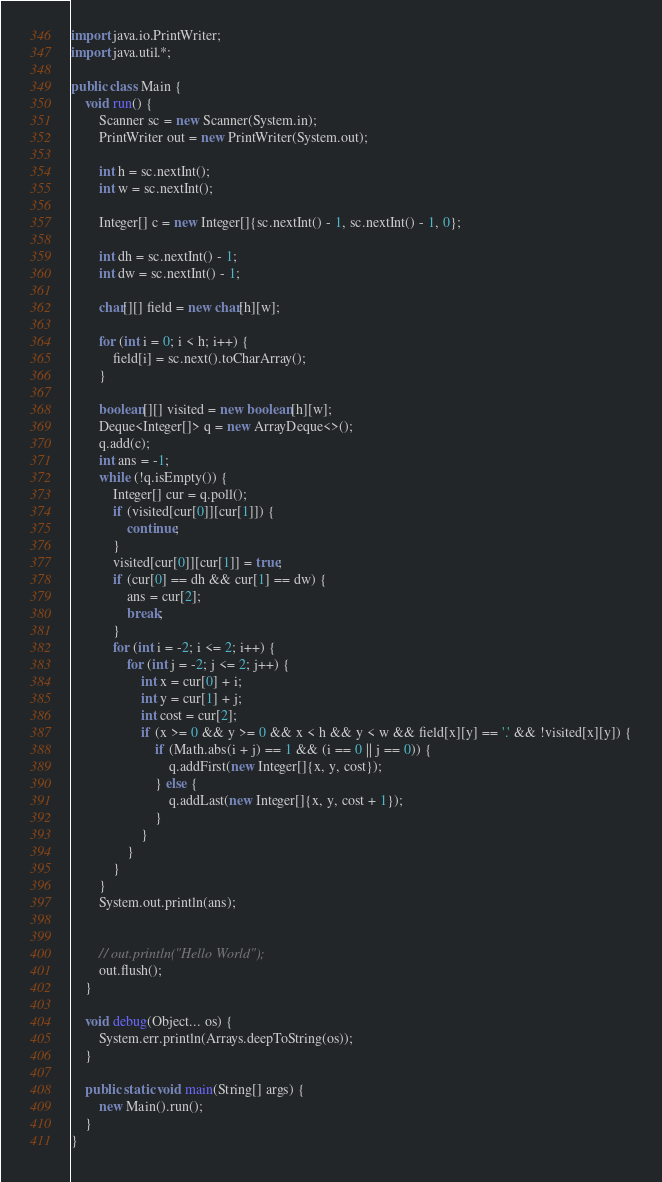<code> <loc_0><loc_0><loc_500><loc_500><_Java_>
import java.io.PrintWriter;
import java.util.*;

public class Main {
    void run() {
        Scanner sc = new Scanner(System.in);
        PrintWriter out = new PrintWriter(System.out);

        int h = sc.nextInt();
        int w = sc.nextInt();

        Integer[] c = new Integer[]{sc.nextInt() - 1, sc.nextInt() - 1, 0};

        int dh = sc.nextInt() - 1;
        int dw = sc.nextInt() - 1;

        char[][] field = new char[h][w];

        for (int i = 0; i < h; i++) {
            field[i] = sc.next().toCharArray();
        }

        boolean[][] visited = new boolean[h][w];
        Deque<Integer[]> q = new ArrayDeque<>();
        q.add(c);
        int ans = -1;
        while (!q.isEmpty()) {
            Integer[] cur = q.poll();
            if (visited[cur[0]][cur[1]]) {
                continue;
            }
            visited[cur[0]][cur[1]] = true;
            if (cur[0] == dh && cur[1] == dw) {
                ans = cur[2];
                break;
            }
            for (int i = -2; i <= 2; i++) {
                for (int j = -2; j <= 2; j++) {
                    int x = cur[0] + i;
                    int y = cur[1] + j;
                    int cost = cur[2];
                    if (x >= 0 && y >= 0 && x < h && y < w && field[x][y] == '.' && !visited[x][y]) {
                        if (Math.abs(i + j) == 1 && (i == 0 || j == 0)) {
                            q.addFirst(new Integer[]{x, y, cost});
                        } else {
                            q.addLast(new Integer[]{x, y, cost + 1});
                        }
                    }
                }
            }
        }
        System.out.println(ans);


        // out.println("Hello World");
        out.flush();
    }

    void debug(Object... os) {
        System.err.println(Arrays.deepToString(os));
    }

    public static void main(String[] args) {
        new Main().run();
    }
}
</code> 